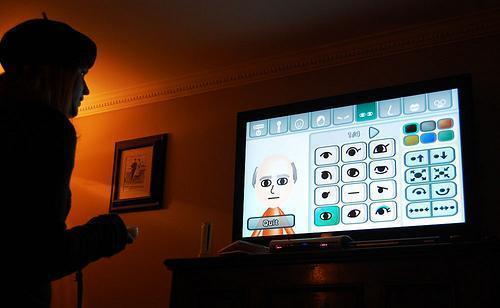Why are there eyes on the screen?
Select the accurate answer and provide explanation: 'Answer: answer
Rationale: rationale.'
Options: People watching, getting glasses, playing solitaire, customizing avatar. Answer: customizing avatar.
Rationale: There is a cartoon person with eye choices on the screen 